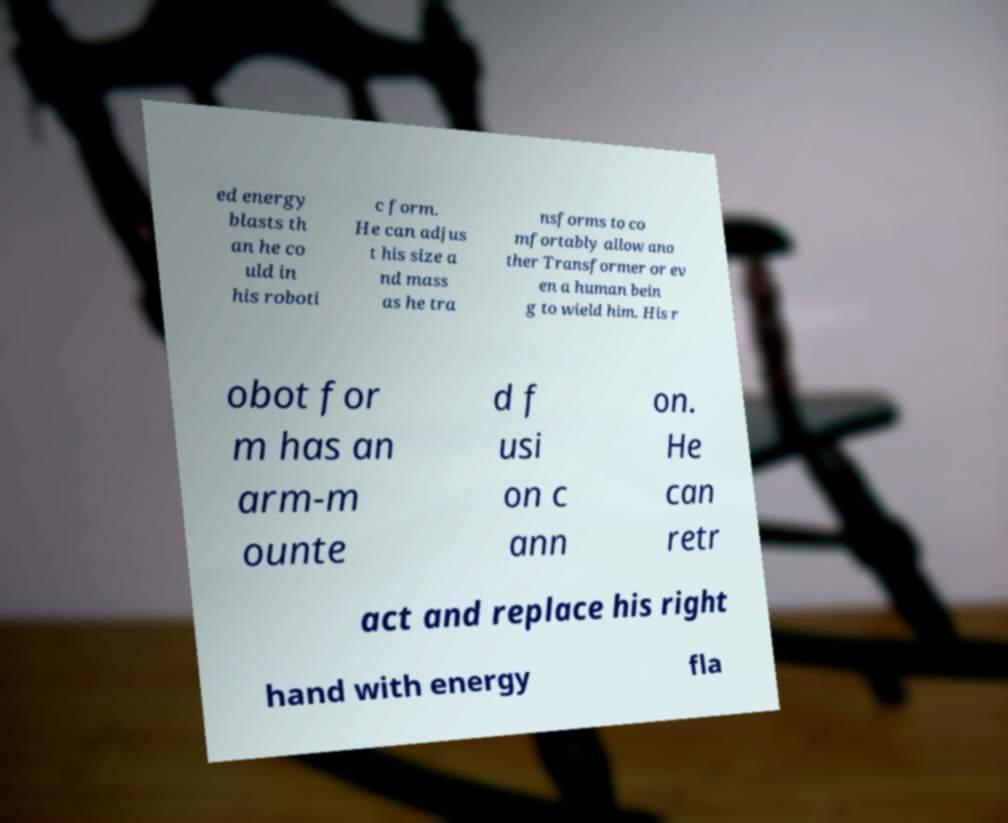Please identify and transcribe the text found in this image. ed energy blasts th an he co uld in his roboti c form. He can adjus t his size a nd mass as he tra nsforms to co mfortably allow ano ther Transformer or ev en a human bein g to wield him. His r obot for m has an arm-m ounte d f usi on c ann on. He can retr act and replace his right hand with energy fla 